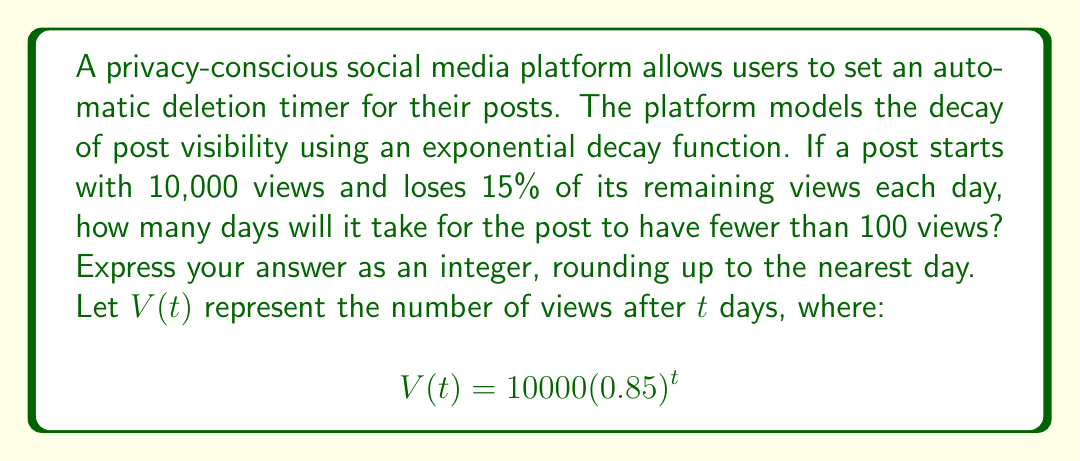Solve this math problem. To solve this problem, we need to find the value of $t$ when $V(t) < 100$. Let's approach this step-by-step:

1) We start with the exponential decay function:
   $$V(t) = 10000(0.85)^t$$

2) We want to find $t$ when $V(t) < 100$. So, we set up the inequality:
   $$10000(0.85)^t < 100$$

3) Divide both sides by 10000:
   $$(0.85)^t < 0.01$$

4) Take the natural logarithm of both sides:
   $$t \ln(0.85) < \ln(0.01)$$

5) Divide both sides by $\ln(0.85)$ (note that $\ln(0.85)$ is negative, so the inequality sign flips):
   $$t > \frac{\ln(0.01)}{\ln(0.85)}$$

6) Calculate the right side:
   $$t > \frac{\ln(0.01)}{\ln(0.85)} \approx 28.4$$

7) Since we need to round up to the nearest day, and we're looking for when the views are fewer than 100, we round up to 29.

It's worth noting that this model assumes continuous decay, which may not perfectly represent real-world view patterns. However, it provides a reasonable approximation for the purpose of this problem.
Answer: 29 days 